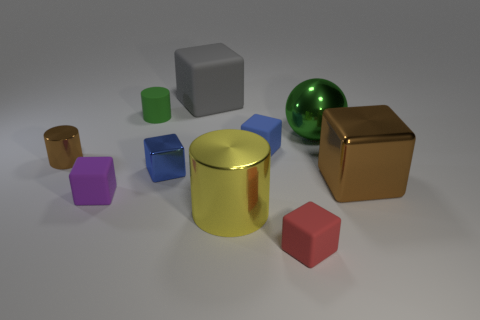How many other things are the same color as the big cylinder?
Offer a very short reply. 0. What number of small green things are there?
Give a very brief answer. 1. What number of large things are both behind the yellow shiny thing and in front of the small rubber cylinder?
Provide a succinct answer. 2. What is the material of the brown block?
Keep it short and to the point. Metal. Is there a tiny rubber cube?
Your answer should be compact. Yes. What color is the metal cylinder that is left of the gray thing?
Offer a very short reply. Brown. What number of metal cylinders are on the left side of the purple matte object on the left side of the brown metal block behind the yellow cylinder?
Provide a succinct answer. 1. The cube that is to the left of the yellow shiny thing and behind the small brown metal cylinder is made of what material?
Make the answer very short. Rubber. Does the large ball have the same material as the brown object that is to the right of the tiny purple matte block?
Your answer should be very brief. Yes. Are there more brown things behind the large brown metallic block than small green objects that are right of the tiny metallic block?
Give a very brief answer. Yes. 